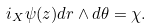Convert formula to latex. <formula><loc_0><loc_0><loc_500><loc_500>i _ { X } \psi ( z ) d r \wedge d \theta = \chi .</formula> 